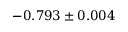Convert formula to latex. <formula><loc_0><loc_0><loc_500><loc_500>- 0 . 7 9 3 \pm 0 . 0 0 4</formula> 